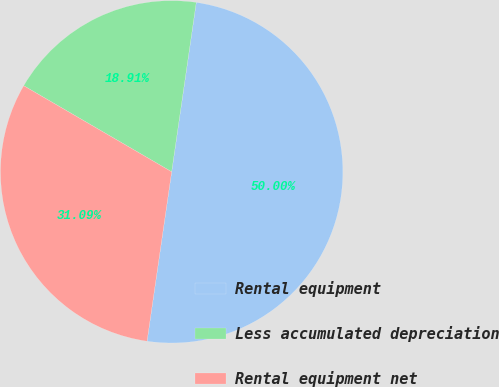Convert chart. <chart><loc_0><loc_0><loc_500><loc_500><pie_chart><fcel>Rental equipment<fcel>Less accumulated depreciation<fcel>Rental equipment net<nl><fcel>50.0%<fcel>18.91%<fcel>31.09%<nl></chart> 